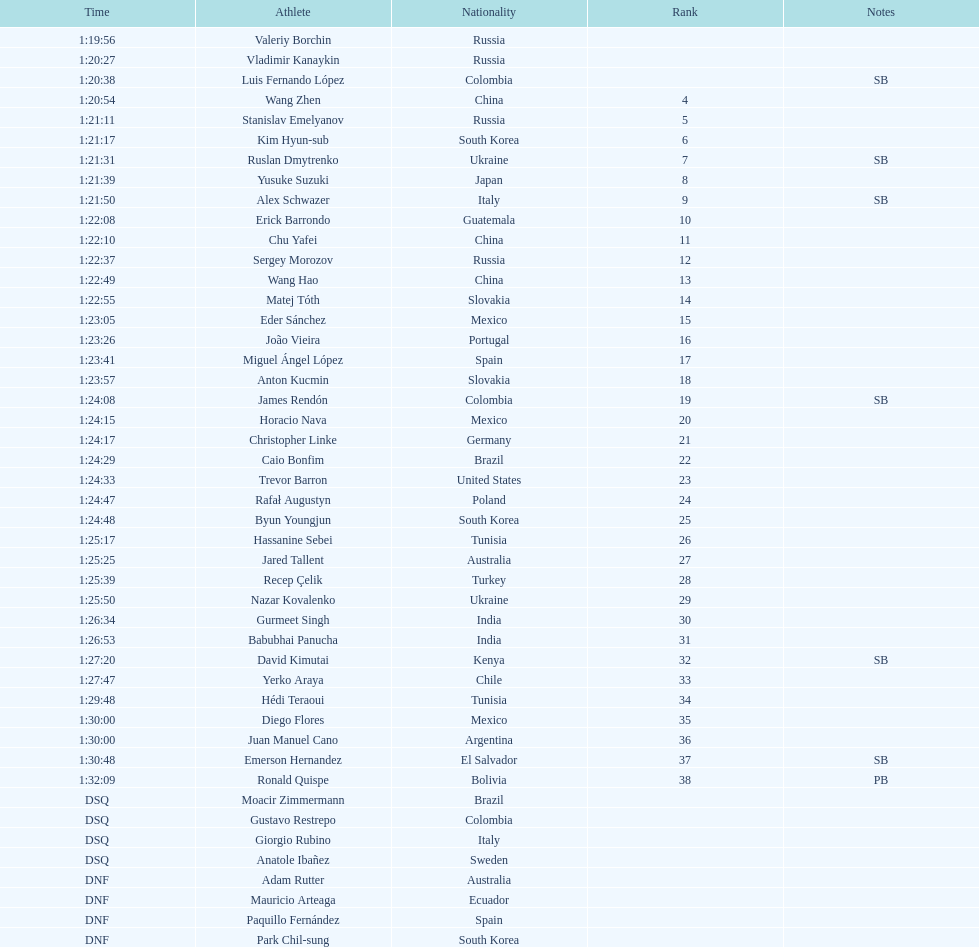Name all athletes were slower than horacio nava. Christopher Linke, Caio Bonfim, Trevor Barron, Rafał Augustyn, Byun Youngjun, Hassanine Sebei, Jared Tallent, Recep Çelik, Nazar Kovalenko, Gurmeet Singh, Babubhai Panucha, David Kimutai, Yerko Araya, Hédi Teraoui, Diego Flores, Juan Manuel Cano, Emerson Hernandez, Ronald Quispe. 